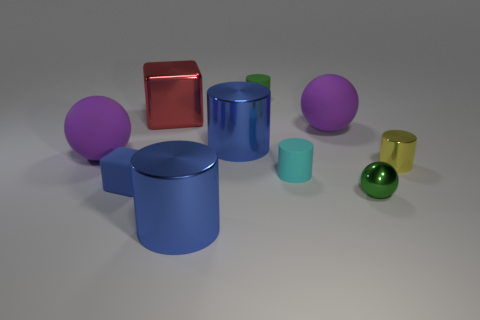Subtract all green metallic spheres. How many spheres are left? 2 Subtract all purple cylinders. How many purple balls are left? 2 Subtract all yellow cylinders. How many cylinders are left? 4 Subtract 3 cylinders. How many cylinders are left? 2 Subtract all blocks. How many objects are left? 8 Subtract all purple things. Subtract all big red objects. How many objects are left? 7 Add 2 small cyan objects. How many small cyan objects are left? 3 Add 9 tiny brown rubber cylinders. How many tiny brown rubber cylinders exist? 9 Subtract 1 yellow cylinders. How many objects are left? 9 Subtract all brown balls. Subtract all purple cylinders. How many balls are left? 3 